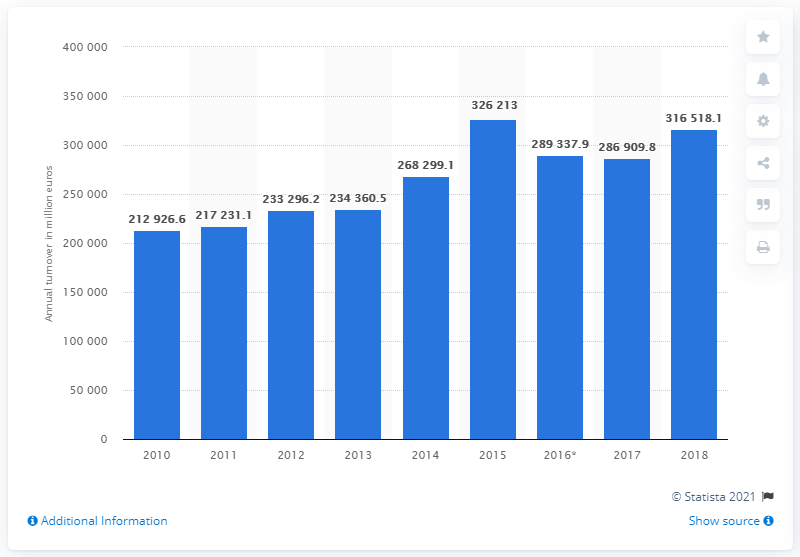Draw attention to some important aspects in this diagram. In 2018, the turnover of the construction industry was 316,518.1. The turnover of the construction industry in 2016 was 286,909.8. 